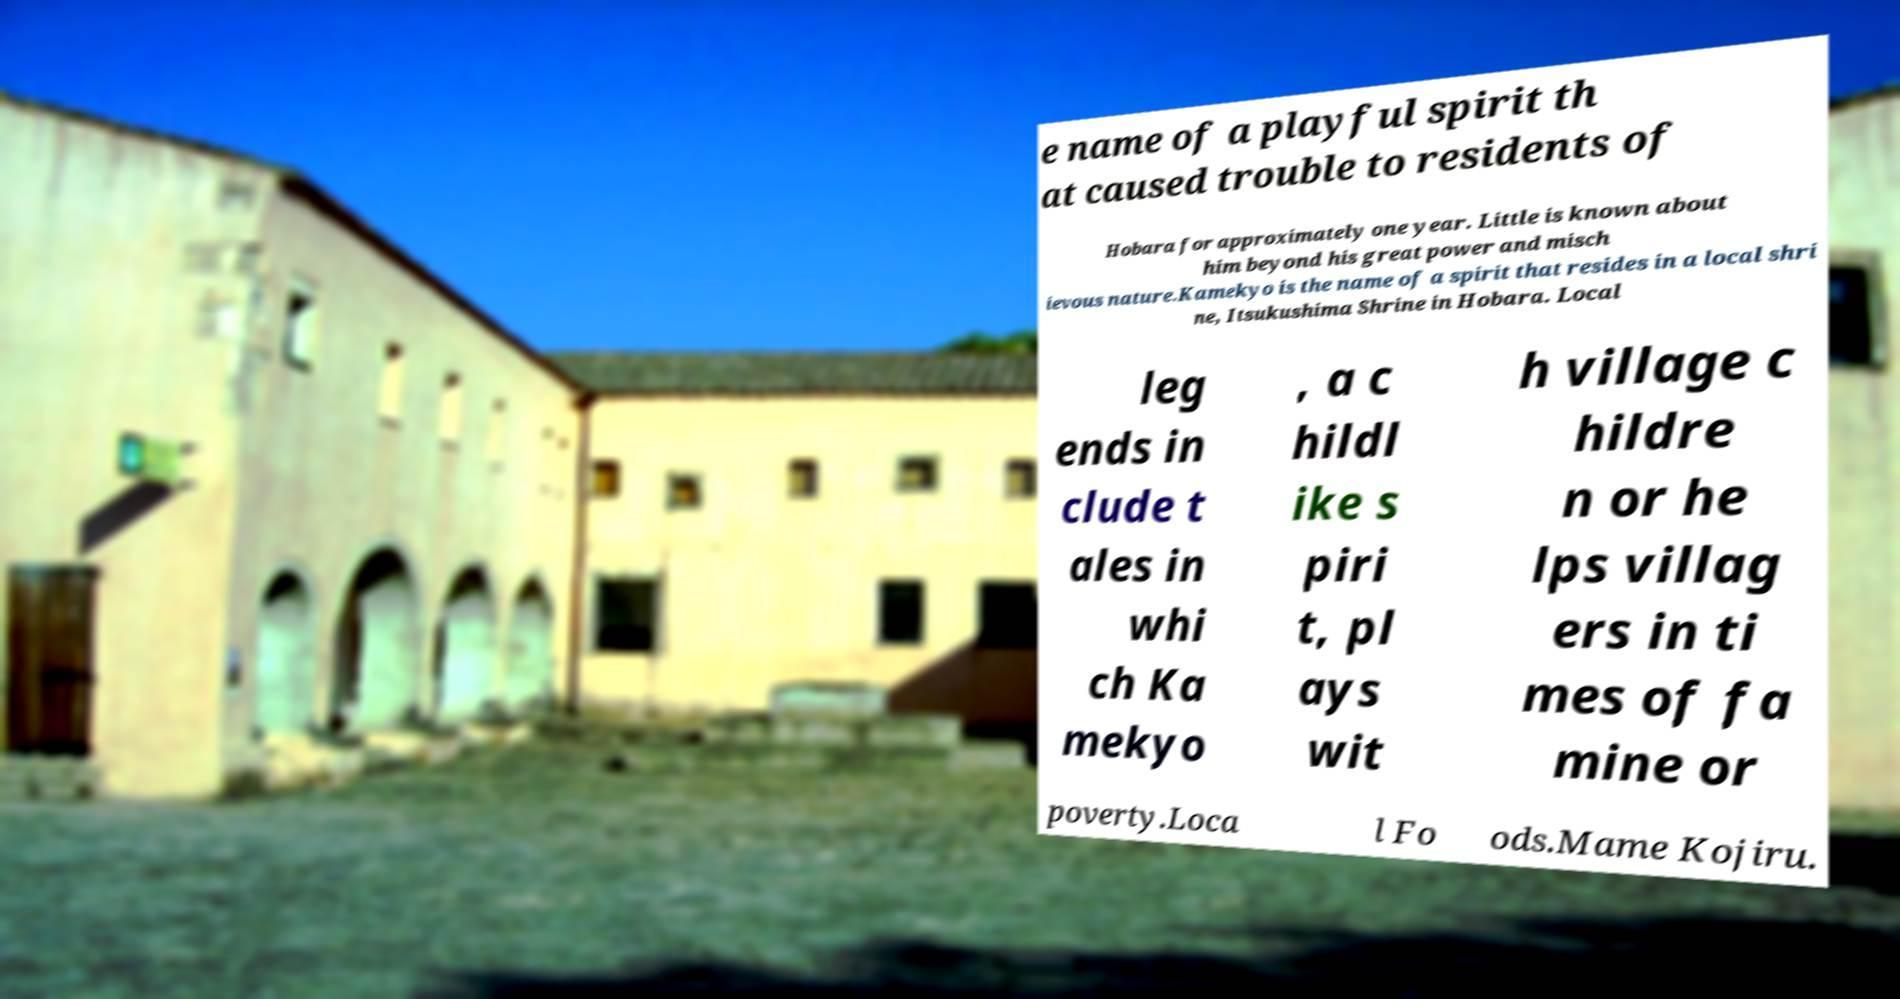For documentation purposes, I need the text within this image transcribed. Could you provide that? e name of a playful spirit th at caused trouble to residents of Hobara for approximately one year. Little is known about him beyond his great power and misch ievous nature.Kamekyo is the name of a spirit that resides in a local shri ne, Itsukushima Shrine in Hobara. Local leg ends in clude t ales in whi ch Ka mekyo , a c hildl ike s piri t, pl ays wit h village c hildre n or he lps villag ers in ti mes of fa mine or poverty.Loca l Fo ods.Mame Kojiru. 